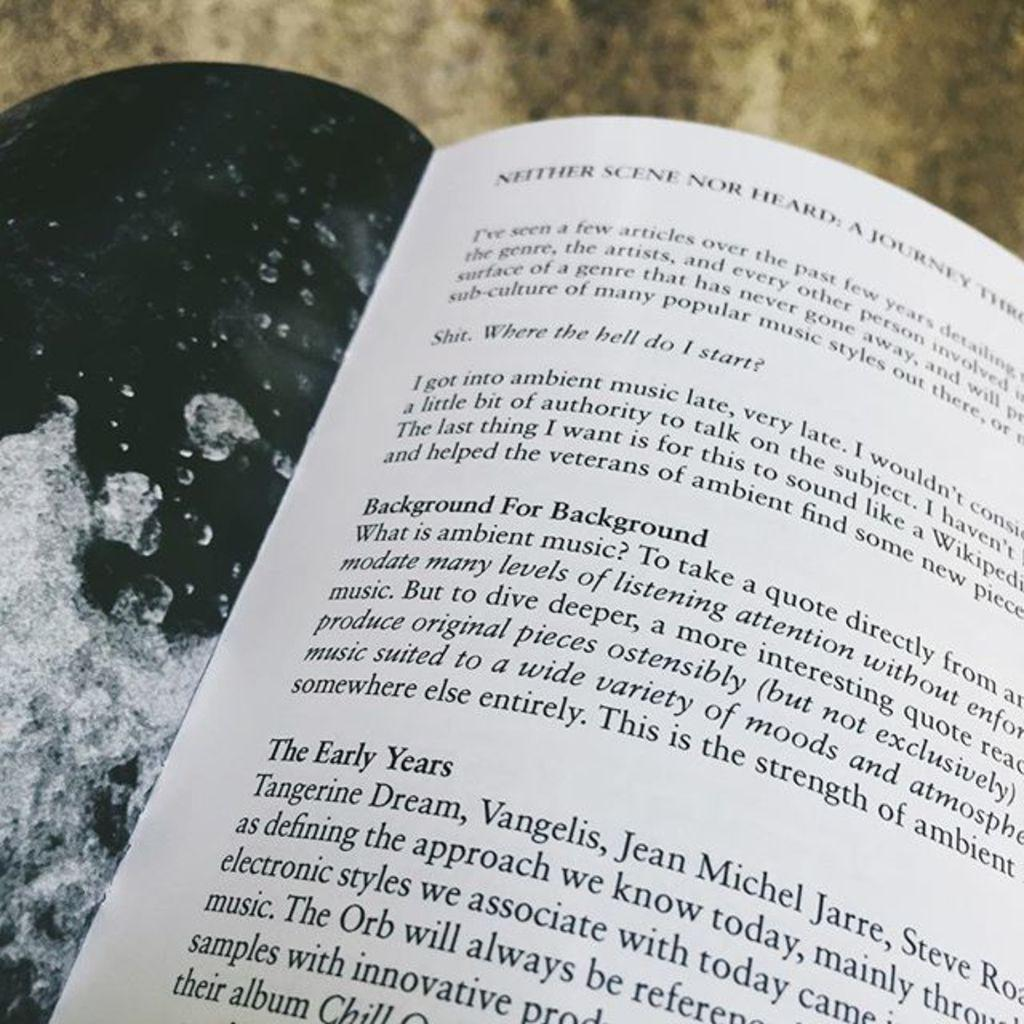<image>
Render a clear and concise summary of the photo. A book that talks about ambient music is open. 